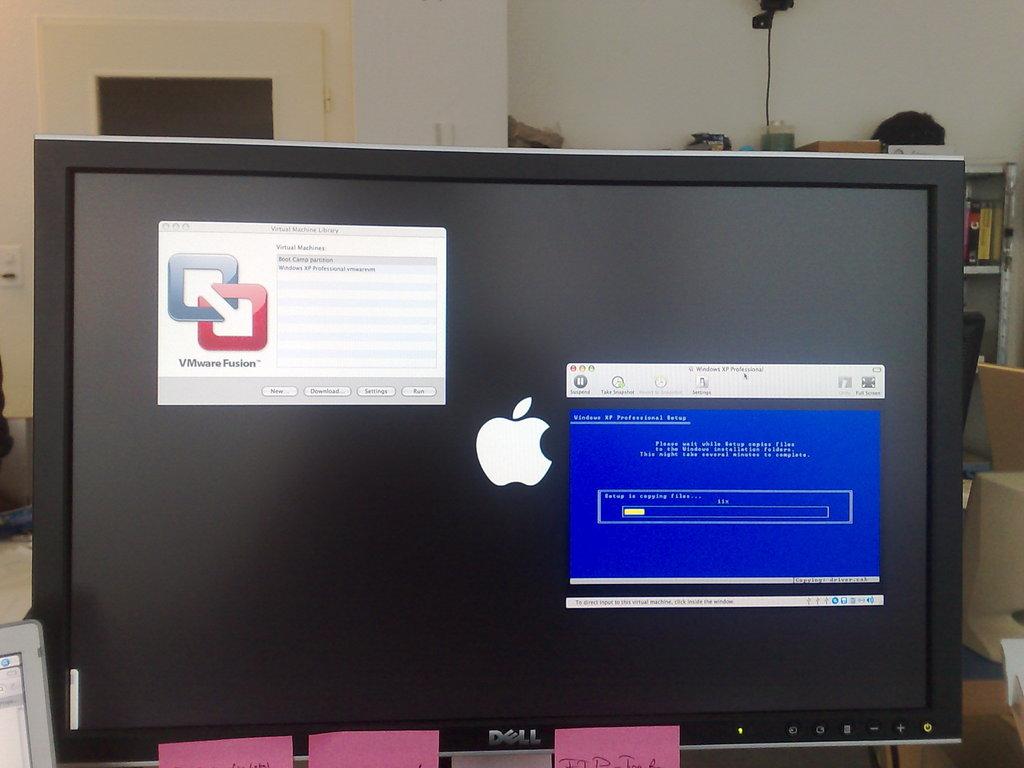What brand is the machine?
Ensure brevity in your answer.  Dell. What is the operatin gsystem?
Keep it short and to the point. Apple. 